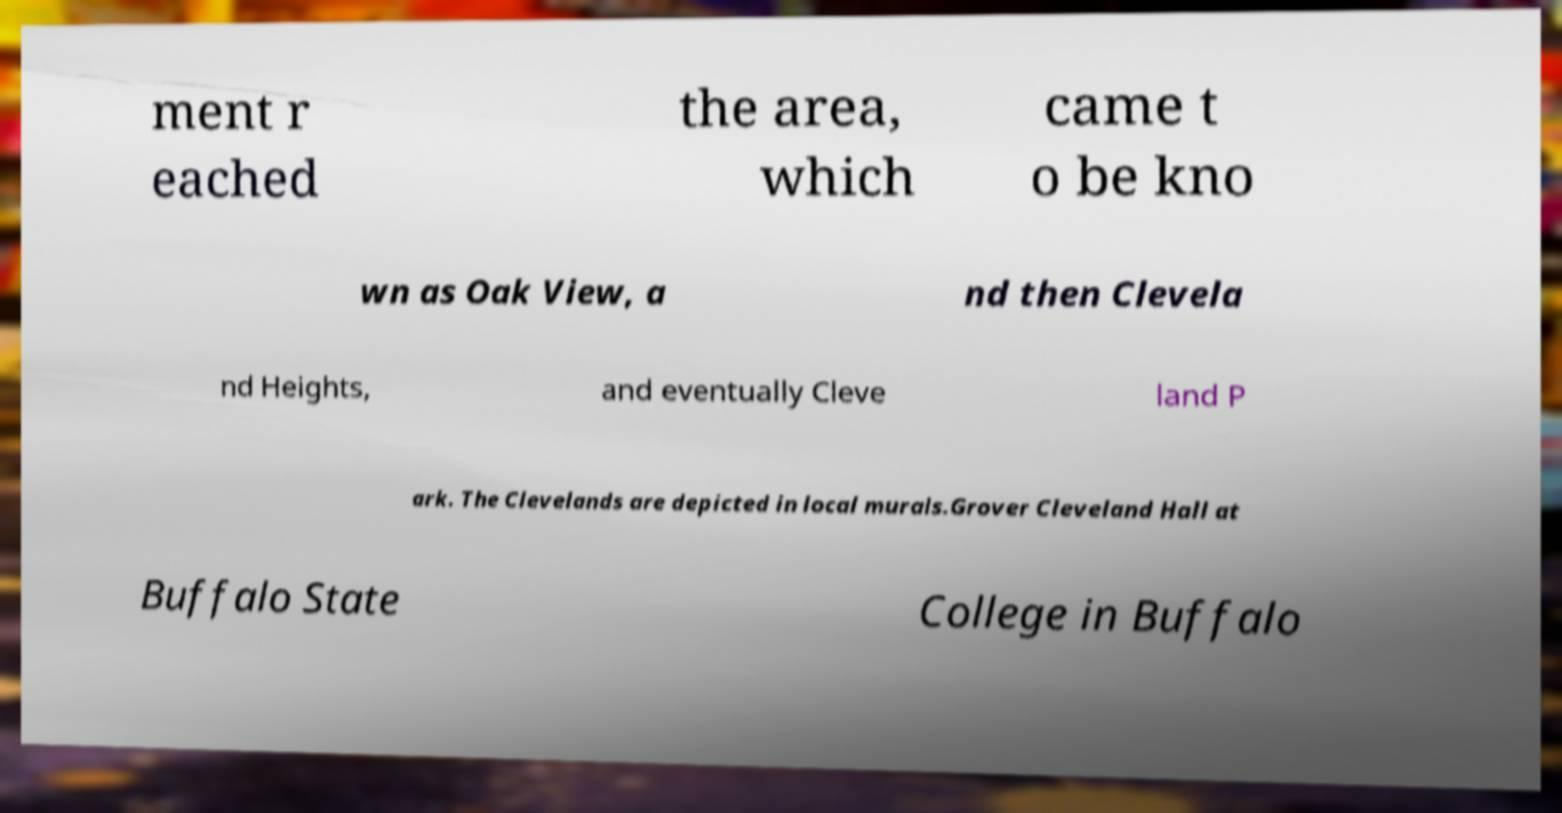I need the written content from this picture converted into text. Can you do that? ment r eached the area, which came t o be kno wn as Oak View, a nd then Clevela nd Heights, and eventually Cleve land P ark. The Clevelands are depicted in local murals.Grover Cleveland Hall at Buffalo State College in Buffalo 